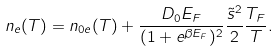Convert formula to latex. <formula><loc_0><loc_0><loc_500><loc_500>n _ { e } ( T ) = n _ { 0 e } ( T ) + \frac { D _ { 0 } E _ { F } } { ( 1 + e ^ { \beta E _ { F } } ) ^ { 2 } } \frac { \tilde { s } ^ { 2 } } { 2 } \frac { T _ { F } } { T } .</formula> 